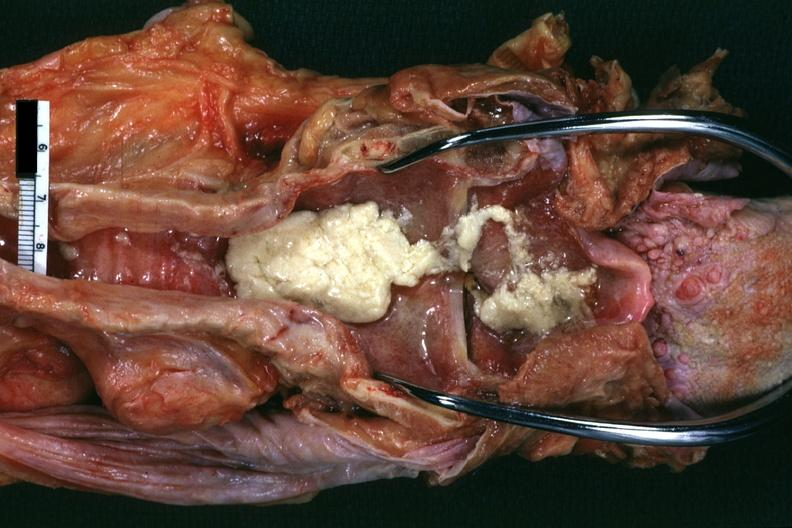what does this image show?
Answer the question using a single word or phrase. Aspirated mucus excellent 